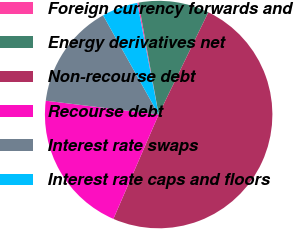Convert chart. <chart><loc_0><loc_0><loc_500><loc_500><pie_chart><fcel>Foreign currency forwards and<fcel>Energy derivatives net<fcel>Non-recourse debt<fcel>Recourse debt<fcel>Interest rate swaps<fcel>Interest rate caps and floors<nl><fcel>0.19%<fcel>10.02%<fcel>49.32%<fcel>20.43%<fcel>14.93%<fcel>5.11%<nl></chart> 